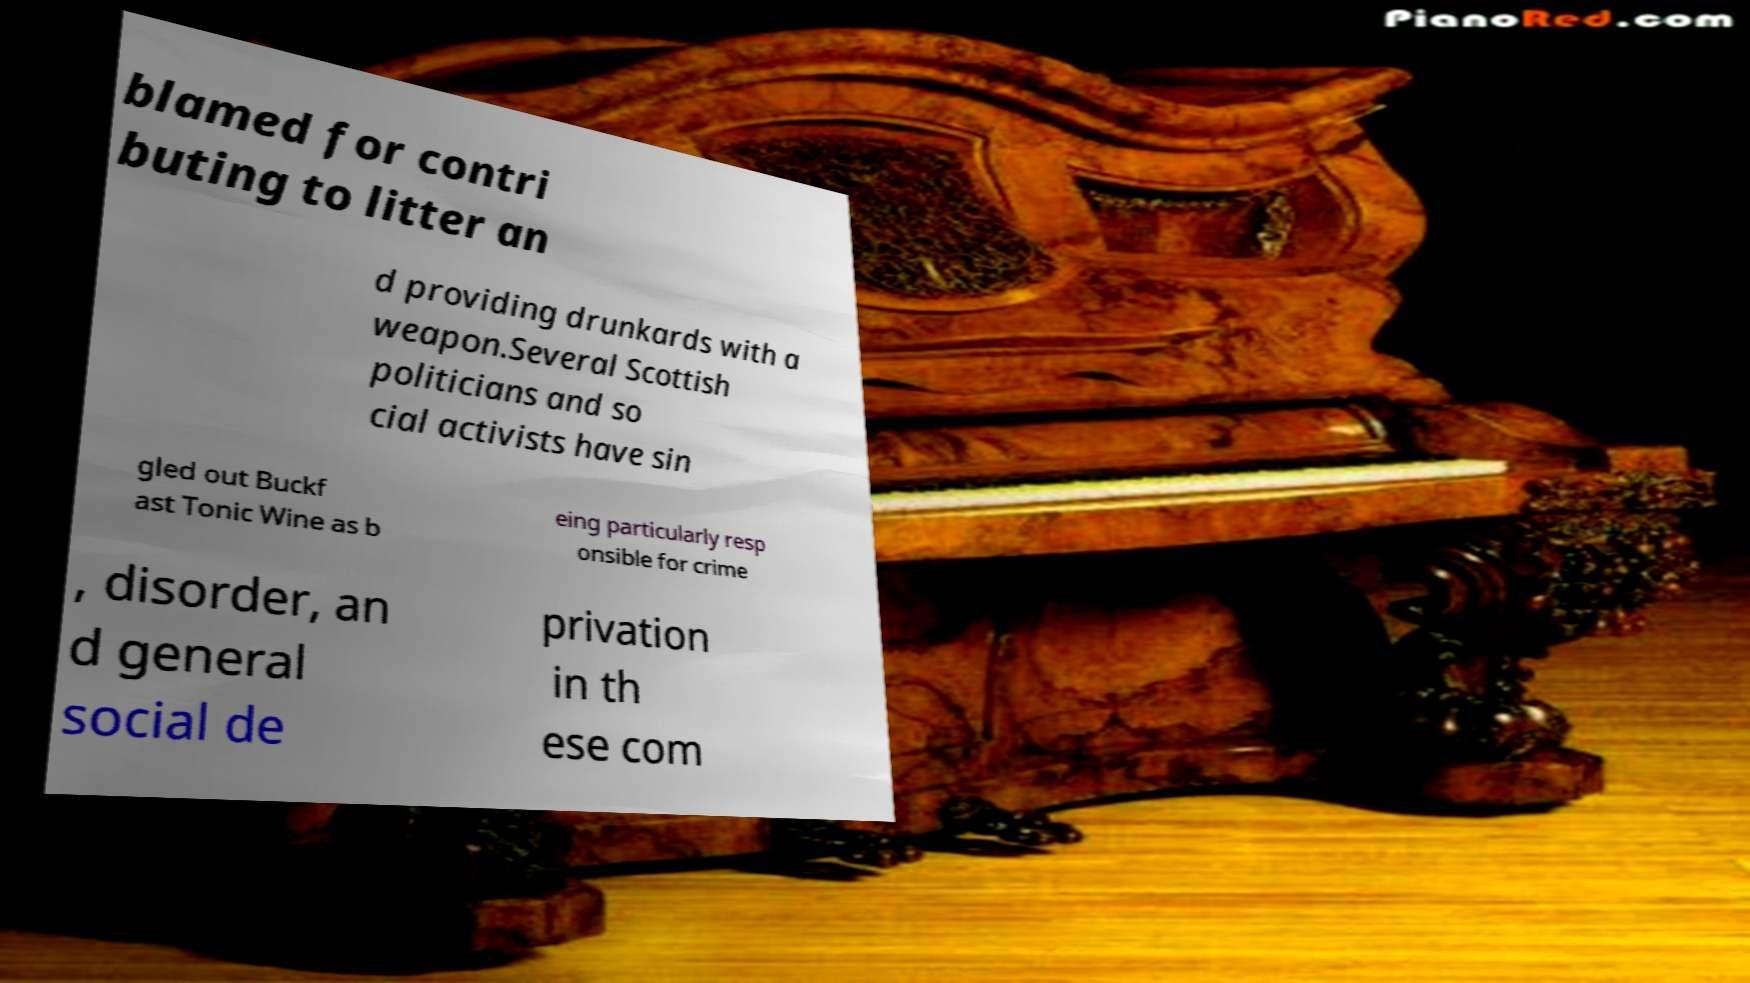There's text embedded in this image that I need extracted. Can you transcribe it verbatim? blamed for contri buting to litter an d providing drunkards with a weapon.Several Scottish politicians and so cial activists have sin gled out Buckf ast Tonic Wine as b eing particularly resp onsible for crime , disorder, an d general social de privation in th ese com 